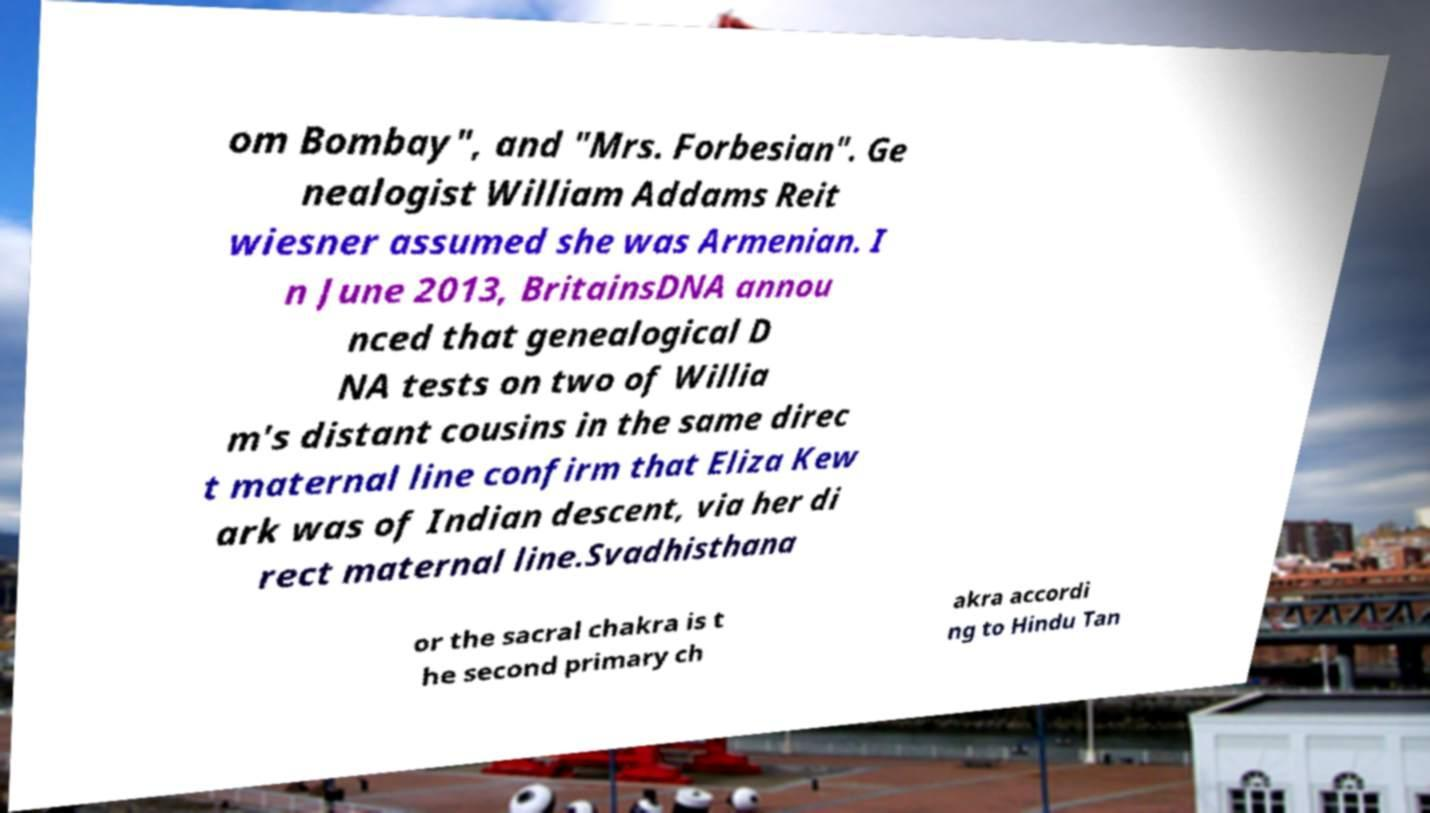There's text embedded in this image that I need extracted. Can you transcribe it verbatim? om Bombay", and "Mrs. Forbesian". Ge nealogist William Addams Reit wiesner assumed she was Armenian. I n June 2013, BritainsDNA annou nced that genealogical D NA tests on two of Willia m's distant cousins in the same direc t maternal line confirm that Eliza Kew ark was of Indian descent, via her di rect maternal line.Svadhisthana or the sacral chakra is t he second primary ch akra accordi ng to Hindu Tan 